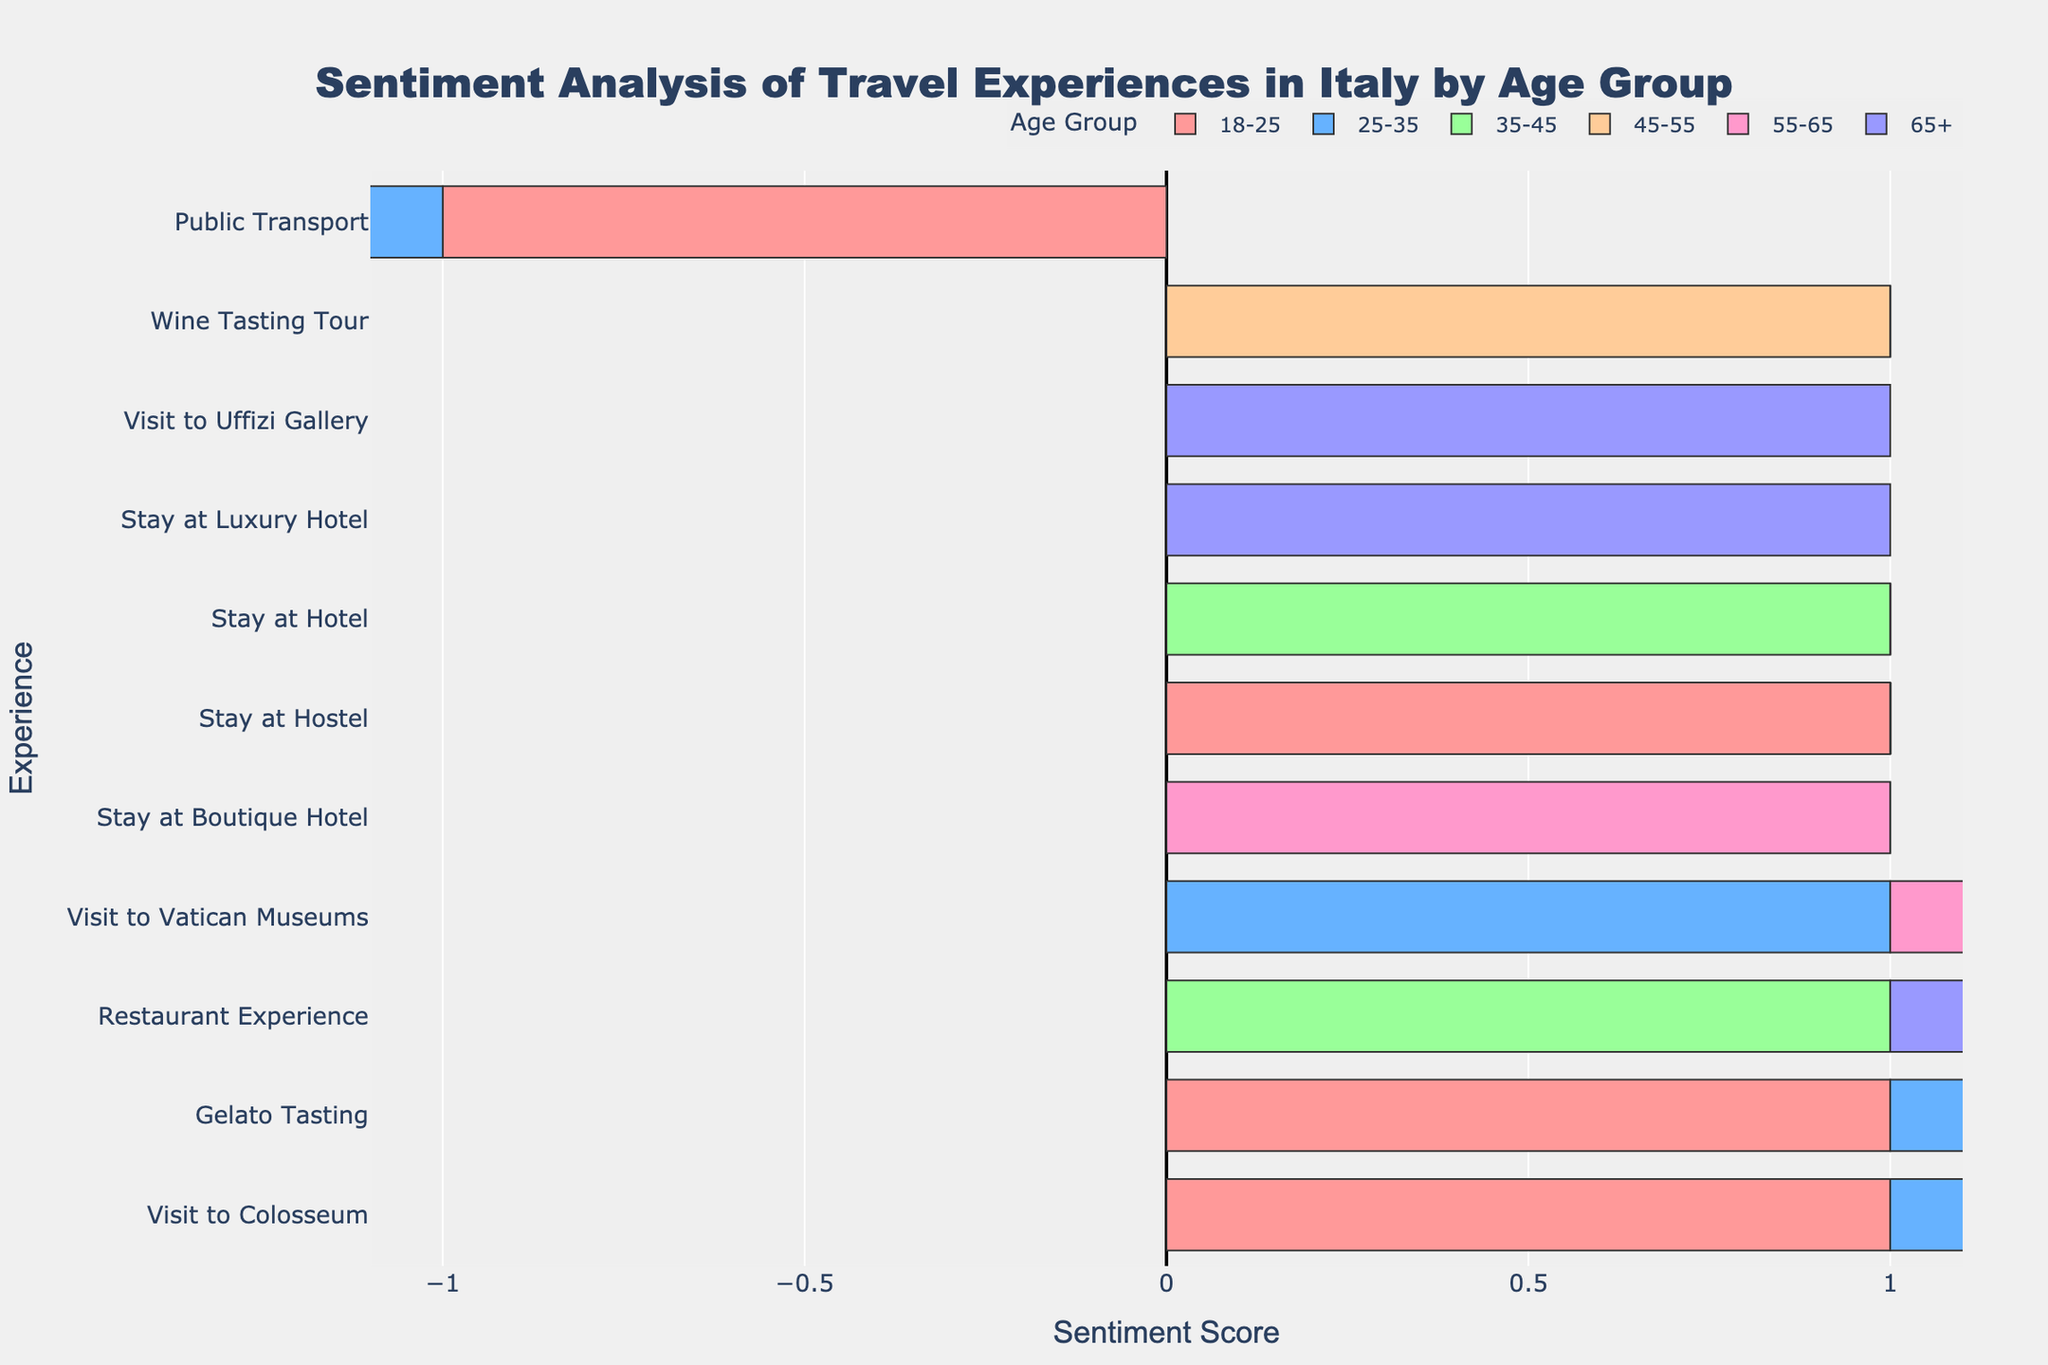What's the overall sentiment towards the Colosseum across all age groups? To determine the overall sentiment for the Colosseum, check the sentiment scores for each age group. Each age group (18-25, 25-35, 35-45, 45-55, 55-65, 65+) shows a positive sentiment score of 1. Summing these scores and averaging, we get (1+1+1+1+1+1)/6 = 1. Thus, the overall sentiment is positive.
Answer: Positive Which age group has the least positive experience with public transport? Look at the sentiment scores for public transport across all age groups. All age groups (18-25, 25-35, 35-45, 45-55, 55-65) have a negative sentiment score for public transport, all being -1. Hence, no single age group has a lesser positive experience than the others.
Answer: All groups equally negative Which experience had the most neutral sentiment and in which age group? Check all experiences for 'Neutral' sentiment scores. Only the 'Visit to Vatican Museums' for the age group 45-55 has a neutral sentiment score (0).
Answer: Visit to Vatican Museums (45-55) For the experience 'Gelato Tasting', how do the sentiments compare between the age groups 18-25 and 25-35? Compare the sentiment scores for Gelato Tasting between the age groups 18-25 and 25-35. Both have a sentiment score of 1, indicating positive experiences in both age groups.
Answer: Equally positive Which experience has the highest variability in sentiment scores across age groups, and what is this variability? Calculate the range of sentiment scores (max score - min score) for each experience. For 'Public Transport' with scores mostly -1 across age groups and one neutral score of 0, the variability is 0 - (-1) = 1. Thus, 'Public Transport' has the highest variability.
Answer: Public Transport, variability of 1 How does the sentiment of 'Stay at Hostel' compare to 'Stay at Hotel' across age groups? Compare the sentiment scores of 'Stay at Hostel' (positive sentiment for the age group 18-25) and 'Stay at Hotel' (positive sentiment for the age group 35-45). Both have a positive sentiment score of 1 for their respective age groups.
Answer: Equally positive What color represents sentiments of the age group 65+ in the plot? Check the color assigned to the 65+ age group in the legend. The color for the age group 65+ is the last one, represented by the sixth color. This would be a hue like the one assigned last in the creation of the plot.
Answer: Purple (assuming last color is purple in 6-color spectrum) What's the average sentiment score for experiences in the age group of 25-35? Sum the sentiment scores for 25-35 age group (Colosseum: 1, Vatican Museums: 1, Gelato Tasting: 1, Public Transport: -1) totaling 2. With 4 experiences, the average sentiment score is 2/4 = 0.5.
Answer: 0.5 What's the sentiment score of the oldest age group (65+) for 'Restaurant Experience'? Look up the sentiment score for 'Restaurant Experience' under the 65+ category, showing a positive sentiment with a score of 1.
Answer: 1 